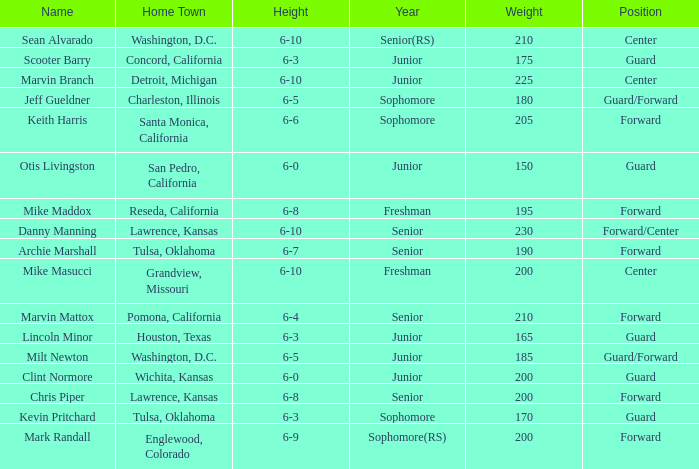Can you tell me the average Weight that has Height of 6-9? 200.0. 